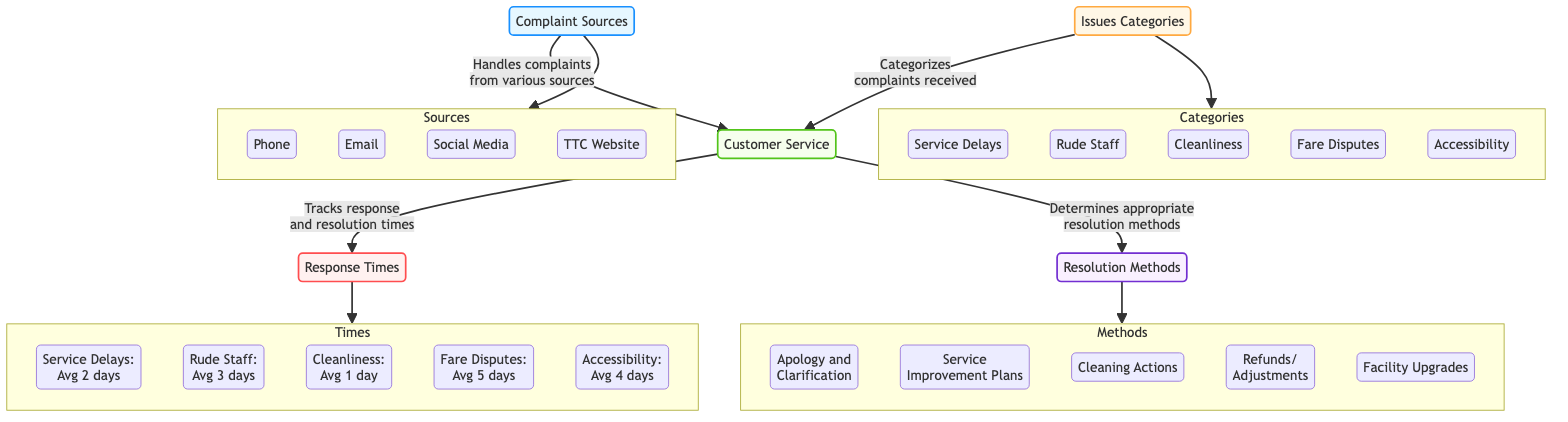What are the complaint sources listed in the diagram? The diagram lists four complaint sources under "Complaint Sources": Phone, Email, Social Media, and TTC Website.
Answer: Phone, Email, Social Media, TTC Website Which issue category has the longest average response time? By examining the response times for each category, "Fare Disputes" has the longest average response time of 5 days.
Answer: Fare Disputes How many total issue categories are presented in the diagram? The diagram shows a total of five issue categories: Service Delays, Rude Staff, Cleanliness, Fare Disputes, and Accessibility.
Answer: 5 What is the average response time for Cleanliness complaints? According to the diagram, the average response time for Cleanliness complaints is 1 day.
Answer: 1 day Which resolution method corresponds to complaints about Rude Staff? The resolution method associated with complaints about Rude Staff is "Apology and Clarification," as indicated in the diagram.
Answer: Apology and Clarification Which complaint source connects to the Customer Service node? All four sources—Phone, Email, Social Media, and TTC Website—connect to the Customer Service node, indicating they funnel complaints into that channel.
Answer: Phone, Email, Social Media, TTC Website What type of nodes are "Service Delays" and "Rude Staff" classified as? Both "Service Delays" and "Rude Staff" are classified as issue category nodes, as labeled in the diagram.
Answer: Issue Category Nodes What is the average response time for Accessibility complaints? The diagram indicates that the average response time for Accessibility complaints is 4 days.
Answer: 4 days How is the connection between the Customer Service node and the response times represented? The connection is shown with an arrow indicating that Customer Service "tracks response and resolution times" which leads to the Response Times node.
Answer: Tracks response and resolution times 